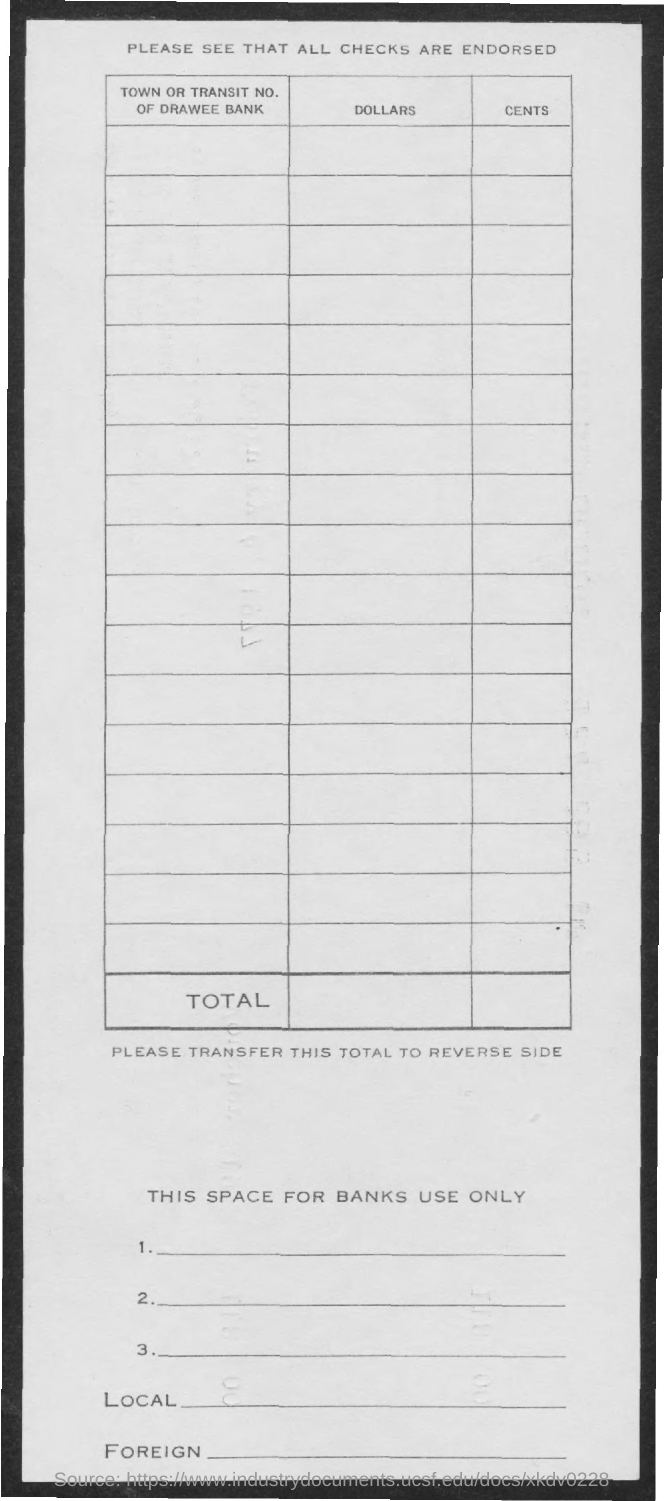Outline some significant characteristics in this image. The title of the second column of the table is "Dollars..". The title of the first column of the table is 'Town or Transit No. of Drawee Bank'. The third column of the table is titled 'Cents.' 